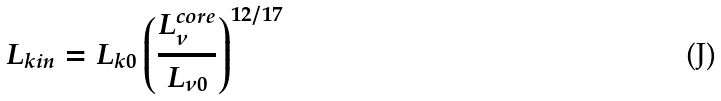<formula> <loc_0><loc_0><loc_500><loc_500>L _ { k i n } = L _ { k 0 } \left ( \frac { L ^ { c o r e } _ { \nu } } { L _ { \nu 0 } } \right ) ^ { 1 2 / 1 7 }</formula> 